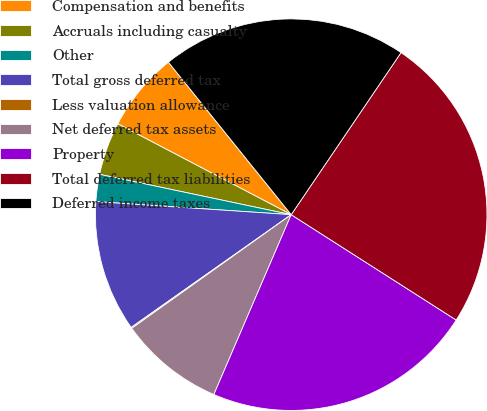Convert chart to OTSL. <chart><loc_0><loc_0><loc_500><loc_500><pie_chart><fcel>Compensation and benefits<fcel>Accruals including casualty<fcel>Other<fcel>Total gross deferred tax<fcel>Less valuation allowance<fcel>Net deferred tax assets<fcel>Property<fcel>Total deferred tax liabilities<fcel>Deferred income taxes<nl><fcel>6.53%<fcel>4.38%<fcel>2.24%<fcel>10.83%<fcel>0.09%<fcel>8.68%<fcel>22.42%<fcel>24.57%<fcel>20.27%<nl></chart> 